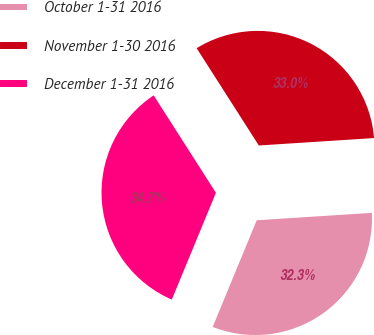<chart> <loc_0><loc_0><loc_500><loc_500><pie_chart><fcel>October 1-31 2016<fcel>November 1-30 2016<fcel>December 1-31 2016<nl><fcel>32.26%<fcel>33.03%<fcel>34.72%<nl></chart> 